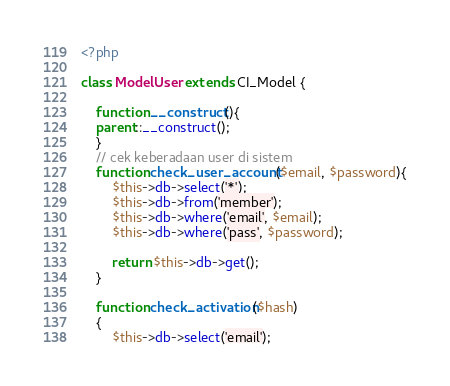<code> <loc_0><loc_0><loc_500><loc_500><_PHP_><?php

class ModelUser extends CI_Model {

	function __construct(){
	parent::__construct();
	}
	// cek keberadaan user di sistem
	function check_user_account($email, $password){
		$this->db->select('*');
		$this->db->from('member');
		$this->db->where('email', $email);
		$this->db->where('pass', $password);

		return $this->db->get();
	}

	function check_activation($hash)
	{
		$this->db->select('email');</code> 